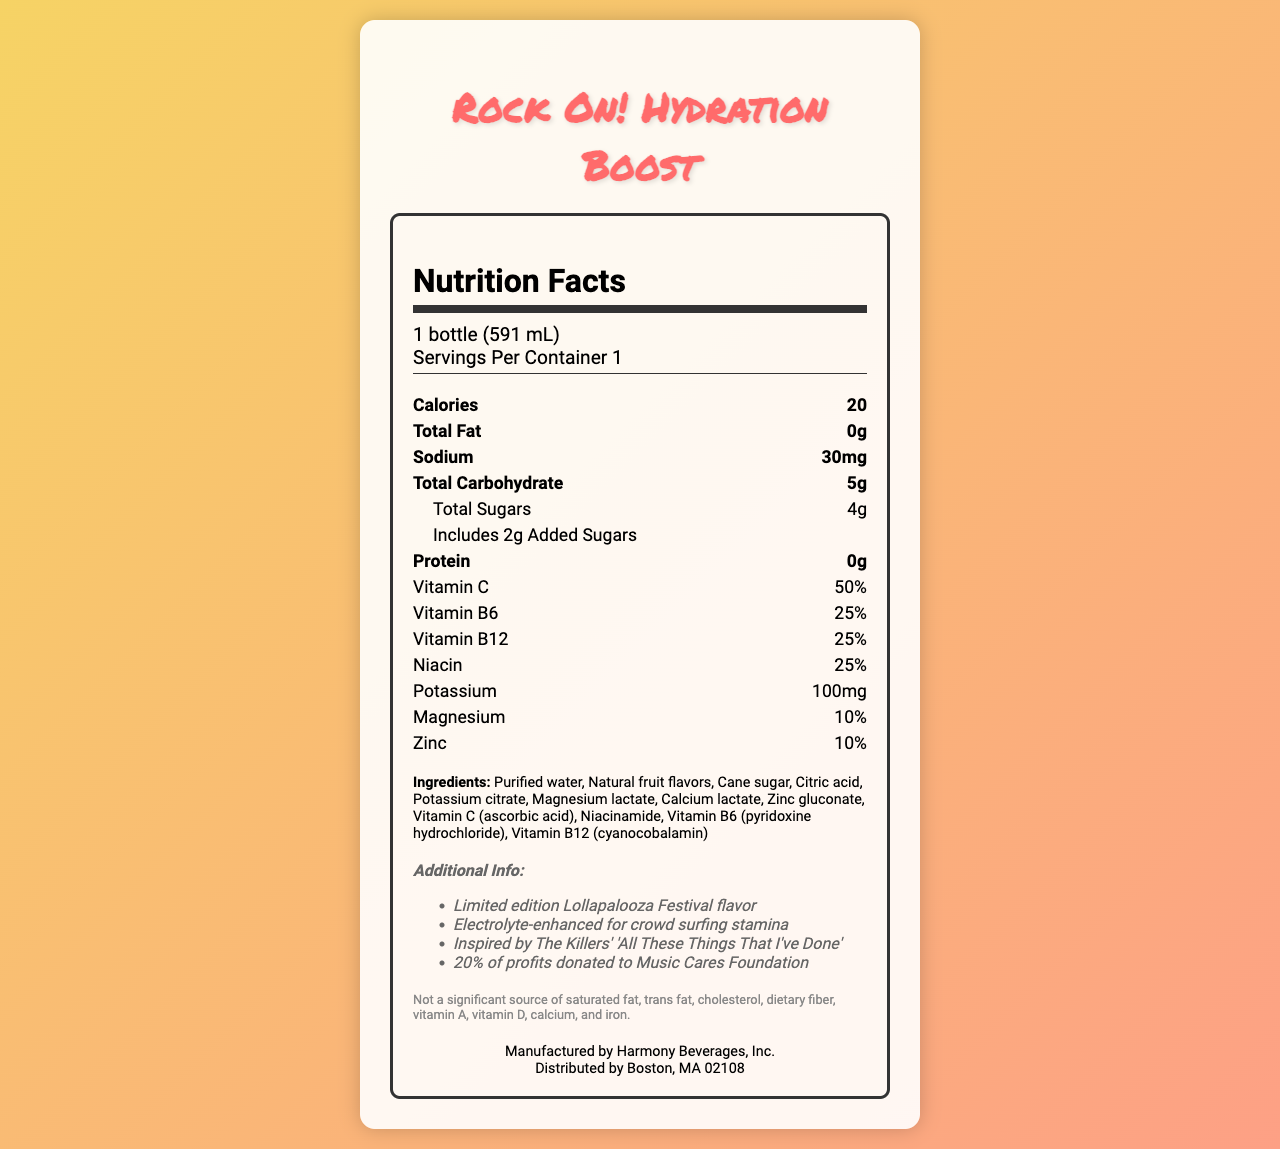what is the serving size? The serving size is clearly listed at the top of the nutrition facts as "1 bottle (591 mL)".
Answer: 1 bottle (591 mL) how many calories are in one serving? The document lists "Calories 20" in the main nutrient section.
Answer: 20 what is the total sugar content in this vitamin water? The nutrition facts state "Total Sugars 4g" under the total carbohydrate section.
Answer: 4g how much vitamin C does this product provide? In the nutrient details, it specifies that the vitamin C content is 50%.
Answer: 50% what are the top three ingredients in this product? The ingredients list is ordered, showing "Purified water", "Natural fruit flavors", and "Cane sugar" as the first three.
Answer: Purified water, Natural fruit flavors, Cane sugar what percentage of vitamin B6 is in this product? The nutrient section lists "Vitamin B6 25%".
Answer: 25% how much added sugar does this vitamin water have? The details under total carbohydrate include "Includes 2g Added Sugars".
Answer: 2g where is this product manufactured and distributed? This information is listed at the bottom under "Manufactured by" and "Distributed by".
Answer: Manufactured by Harmony Beverages, Inc. and distributed by Boston, MA 02108 what additional benefits does this water offer according to the document? The additional info section lists these benefits.
Answer: Limited edition Lollapalooza Festival flavor, Electrolyte-enhanced for crowd surfing stamina, Inspired by The Killers' 'All These Things That I've Done', 20% of profits donated to Music Cares Foundation which electrolyte is present in the highest quantity? A. Calcium B. Potassium C. Magnesium D. Zinc The document lists potassium as 100mg which is higher compared to the other electrolytes.
Answer: B which of the following vitamins is NOT a significant source according to the disclaimer? I. Vitamin A II. Iron III. Vitamin B12 IV. Vitamin D According to the disclaimer, the product is not a significant source of Vitamin A, Iron, and Vitamin D, but it does provide 25% of Vitamin B12.
Answer: I, II, IV is this product suitable for someone with a soy allergy? The allergen info states that it's produced in a facility that processes soy.
Answer: No how many grams of protein are in this bottle? The nutrient section indicates "Protein 0g".
Answer: 0g summarize the main idea of the document. This summary captures the essence of the nutrition facts label and the special features highlighted in the additional information section.
Answer: The document provides the nutrition facts and additional information about "Rock On! Hydration Boost", a limited edition concert-themed vitamin water with electrolytes. It lists the different nutritional content per serving, ingredients, allergens, and special features like being inspired by The Killers and donating profits to Music Cares Foundation. is the product a significant source of dietary fiber? The disclaimer mentions that it's not a significant source of dietary fiber.
Answer: No what inspired the flavor of this product? The additional info mentions that the product is inspired by The Killers' song "All These Things That I've Done".
Answer: The Killers' 'All These Things That I've Done' what is the recommended daily intake of sodium for adults according to the document? The document does not provide information about the recommended daily intake of sodium for adults.
Answer: Cannot be determined 